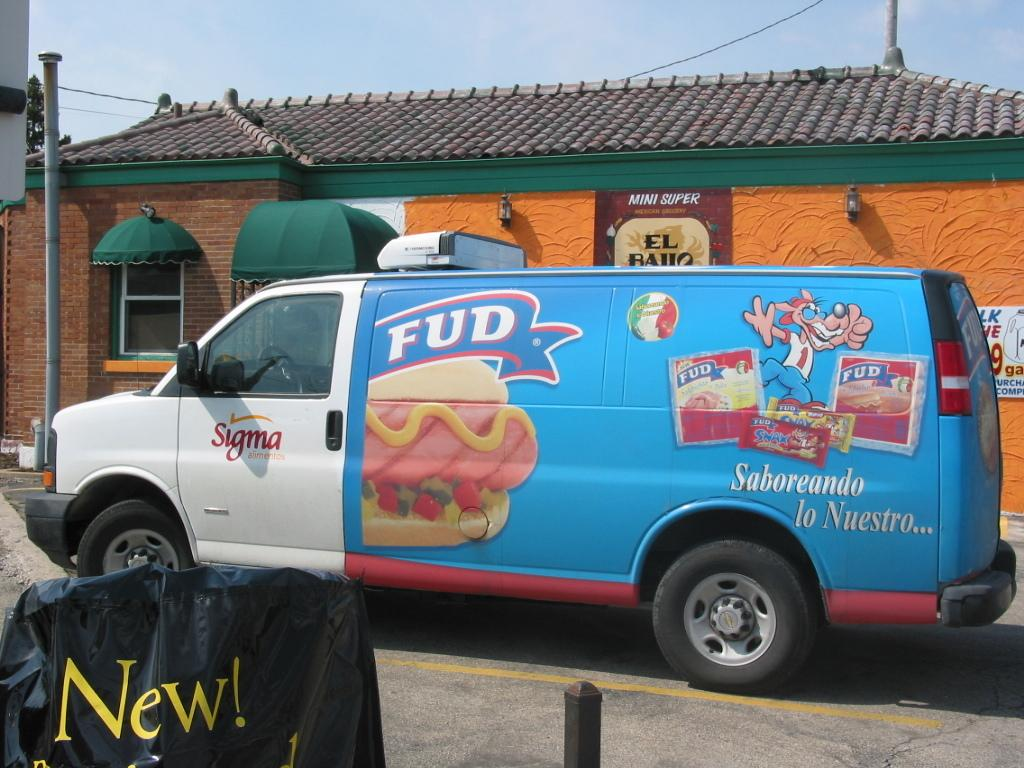<image>
Create a compact narrative representing the image presented. a fud van that is outside in daytime 